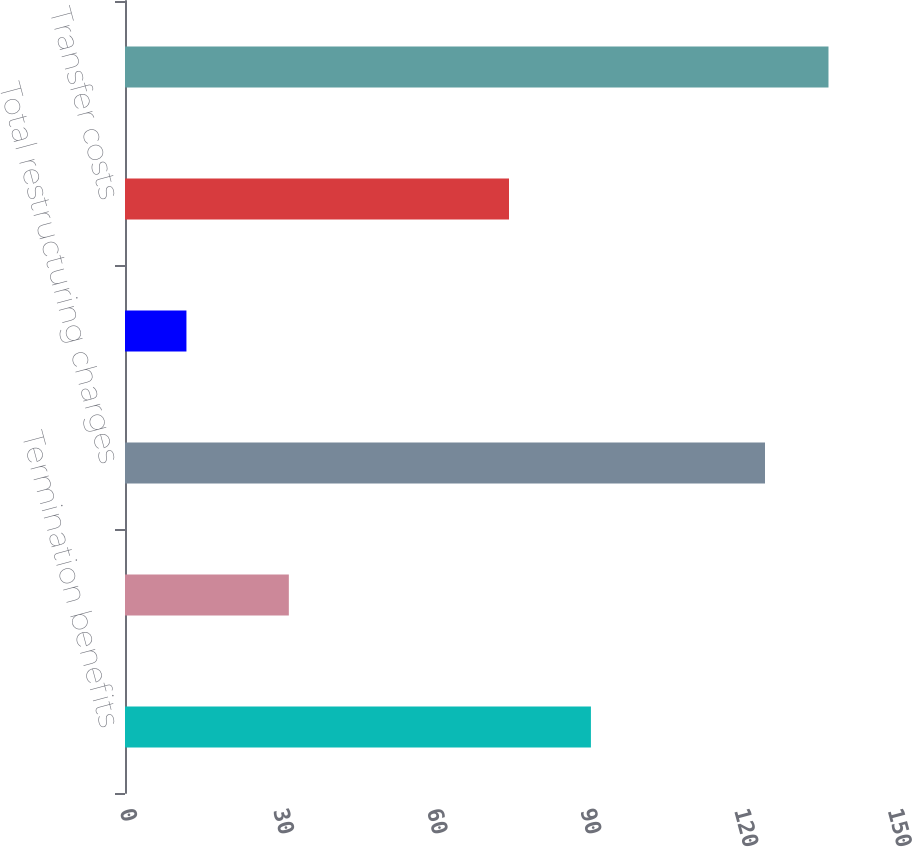Convert chart to OTSL. <chart><loc_0><loc_0><loc_500><loc_500><bar_chart><fcel>Termination benefits<fcel>Other<fcel>Total restructuring charges<fcel>Accelerated depreciation<fcel>Transfer costs<fcel>Restructuring-related expenses<nl><fcel>91<fcel>32<fcel>125<fcel>12<fcel>75<fcel>137.4<nl></chart> 